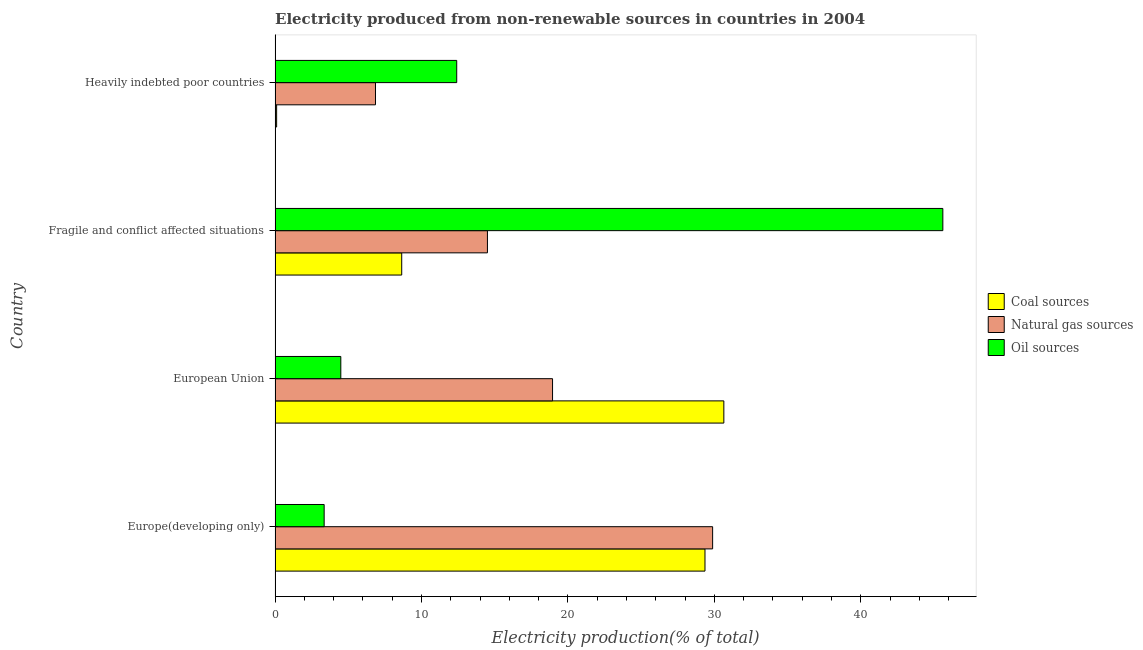How many different coloured bars are there?
Your answer should be very brief. 3. Are the number of bars per tick equal to the number of legend labels?
Provide a short and direct response. Yes. How many bars are there on the 2nd tick from the top?
Your answer should be compact. 3. How many bars are there on the 3rd tick from the bottom?
Offer a terse response. 3. What is the label of the 4th group of bars from the top?
Offer a very short reply. Europe(developing only). What is the percentage of electricity produced by oil sources in European Union?
Your answer should be compact. 4.49. Across all countries, what is the maximum percentage of electricity produced by oil sources?
Your response must be concise. 45.6. Across all countries, what is the minimum percentage of electricity produced by coal?
Provide a succinct answer. 0.11. In which country was the percentage of electricity produced by natural gas maximum?
Provide a short and direct response. Europe(developing only). In which country was the percentage of electricity produced by oil sources minimum?
Your response must be concise. Europe(developing only). What is the total percentage of electricity produced by oil sources in the graph?
Your answer should be very brief. 65.85. What is the difference between the percentage of electricity produced by natural gas in European Union and that in Fragile and conflict affected situations?
Make the answer very short. 4.45. What is the difference between the percentage of electricity produced by oil sources in Fragile and conflict affected situations and the percentage of electricity produced by natural gas in European Union?
Your response must be concise. 26.65. What is the average percentage of electricity produced by coal per country?
Provide a succinct answer. 17.19. What is the difference between the percentage of electricity produced by natural gas and percentage of electricity produced by oil sources in European Union?
Your answer should be very brief. 14.46. In how many countries, is the percentage of electricity produced by natural gas greater than 6 %?
Your response must be concise. 4. What is the ratio of the percentage of electricity produced by oil sources in European Union to that in Heavily indebted poor countries?
Keep it short and to the point. 0.36. Is the percentage of electricity produced by coal in European Union less than that in Heavily indebted poor countries?
Make the answer very short. No. What is the difference between the highest and the second highest percentage of electricity produced by coal?
Ensure brevity in your answer.  1.29. What is the difference between the highest and the lowest percentage of electricity produced by natural gas?
Make the answer very short. 23.02. Is the sum of the percentage of electricity produced by oil sources in European Union and Fragile and conflict affected situations greater than the maximum percentage of electricity produced by natural gas across all countries?
Keep it short and to the point. Yes. What does the 1st bar from the top in Fragile and conflict affected situations represents?
Your answer should be compact. Oil sources. What does the 3rd bar from the bottom in Fragile and conflict affected situations represents?
Your answer should be compact. Oil sources. Are all the bars in the graph horizontal?
Give a very brief answer. Yes. Are the values on the major ticks of X-axis written in scientific E-notation?
Make the answer very short. No. How are the legend labels stacked?
Your answer should be very brief. Vertical. What is the title of the graph?
Provide a short and direct response. Electricity produced from non-renewable sources in countries in 2004. What is the Electricity production(% of total) in Coal sources in Europe(developing only)?
Give a very brief answer. 29.36. What is the Electricity production(% of total) in Natural gas sources in Europe(developing only)?
Your answer should be very brief. 29.88. What is the Electricity production(% of total) of Oil sources in Europe(developing only)?
Offer a terse response. 3.35. What is the Electricity production(% of total) of Coal sources in European Union?
Your response must be concise. 30.65. What is the Electricity production(% of total) in Natural gas sources in European Union?
Provide a short and direct response. 18.95. What is the Electricity production(% of total) of Oil sources in European Union?
Offer a very short reply. 4.49. What is the Electricity production(% of total) of Coal sources in Fragile and conflict affected situations?
Keep it short and to the point. 8.65. What is the Electricity production(% of total) of Natural gas sources in Fragile and conflict affected situations?
Ensure brevity in your answer.  14.5. What is the Electricity production(% of total) in Oil sources in Fragile and conflict affected situations?
Give a very brief answer. 45.6. What is the Electricity production(% of total) in Coal sources in Heavily indebted poor countries?
Offer a very short reply. 0.11. What is the Electricity production(% of total) in Natural gas sources in Heavily indebted poor countries?
Provide a short and direct response. 6.86. What is the Electricity production(% of total) in Oil sources in Heavily indebted poor countries?
Provide a short and direct response. 12.4. Across all countries, what is the maximum Electricity production(% of total) of Coal sources?
Your response must be concise. 30.65. Across all countries, what is the maximum Electricity production(% of total) of Natural gas sources?
Provide a succinct answer. 29.88. Across all countries, what is the maximum Electricity production(% of total) in Oil sources?
Provide a succinct answer. 45.6. Across all countries, what is the minimum Electricity production(% of total) in Coal sources?
Your answer should be very brief. 0.11. Across all countries, what is the minimum Electricity production(% of total) in Natural gas sources?
Offer a very short reply. 6.86. Across all countries, what is the minimum Electricity production(% of total) in Oil sources?
Keep it short and to the point. 3.35. What is the total Electricity production(% of total) in Coal sources in the graph?
Offer a very short reply. 68.76. What is the total Electricity production(% of total) of Natural gas sources in the graph?
Offer a very short reply. 70.19. What is the total Electricity production(% of total) of Oil sources in the graph?
Give a very brief answer. 65.85. What is the difference between the Electricity production(% of total) of Coal sources in Europe(developing only) and that in European Union?
Offer a terse response. -1.29. What is the difference between the Electricity production(% of total) in Natural gas sources in Europe(developing only) and that in European Union?
Provide a short and direct response. 10.93. What is the difference between the Electricity production(% of total) in Oil sources in Europe(developing only) and that in European Union?
Your answer should be very brief. -1.14. What is the difference between the Electricity production(% of total) of Coal sources in Europe(developing only) and that in Fragile and conflict affected situations?
Your response must be concise. 20.71. What is the difference between the Electricity production(% of total) of Natural gas sources in Europe(developing only) and that in Fragile and conflict affected situations?
Provide a succinct answer. 15.38. What is the difference between the Electricity production(% of total) of Oil sources in Europe(developing only) and that in Fragile and conflict affected situations?
Make the answer very short. -42.25. What is the difference between the Electricity production(% of total) of Coal sources in Europe(developing only) and that in Heavily indebted poor countries?
Your answer should be compact. 29.25. What is the difference between the Electricity production(% of total) of Natural gas sources in Europe(developing only) and that in Heavily indebted poor countries?
Make the answer very short. 23.02. What is the difference between the Electricity production(% of total) in Oil sources in Europe(developing only) and that in Heavily indebted poor countries?
Give a very brief answer. -9.05. What is the difference between the Electricity production(% of total) of Coal sources in European Union and that in Fragile and conflict affected situations?
Your response must be concise. 22. What is the difference between the Electricity production(% of total) of Natural gas sources in European Union and that in Fragile and conflict affected situations?
Your response must be concise. 4.45. What is the difference between the Electricity production(% of total) of Oil sources in European Union and that in Fragile and conflict affected situations?
Give a very brief answer. -41.11. What is the difference between the Electricity production(% of total) in Coal sources in European Union and that in Heavily indebted poor countries?
Your answer should be very brief. 30.54. What is the difference between the Electricity production(% of total) in Natural gas sources in European Union and that in Heavily indebted poor countries?
Your answer should be very brief. 12.09. What is the difference between the Electricity production(% of total) in Oil sources in European Union and that in Heavily indebted poor countries?
Offer a terse response. -7.92. What is the difference between the Electricity production(% of total) in Coal sources in Fragile and conflict affected situations and that in Heavily indebted poor countries?
Ensure brevity in your answer.  8.54. What is the difference between the Electricity production(% of total) in Natural gas sources in Fragile and conflict affected situations and that in Heavily indebted poor countries?
Provide a short and direct response. 7.65. What is the difference between the Electricity production(% of total) of Oil sources in Fragile and conflict affected situations and that in Heavily indebted poor countries?
Make the answer very short. 33.2. What is the difference between the Electricity production(% of total) in Coal sources in Europe(developing only) and the Electricity production(% of total) in Natural gas sources in European Union?
Your response must be concise. 10.41. What is the difference between the Electricity production(% of total) of Coal sources in Europe(developing only) and the Electricity production(% of total) of Oil sources in European Union?
Ensure brevity in your answer.  24.87. What is the difference between the Electricity production(% of total) of Natural gas sources in Europe(developing only) and the Electricity production(% of total) of Oil sources in European Union?
Your response must be concise. 25.39. What is the difference between the Electricity production(% of total) of Coal sources in Europe(developing only) and the Electricity production(% of total) of Natural gas sources in Fragile and conflict affected situations?
Offer a terse response. 14.86. What is the difference between the Electricity production(% of total) in Coal sources in Europe(developing only) and the Electricity production(% of total) in Oil sources in Fragile and conflict affected situations?
Ensure brevity in your answer.  -16.24. What is the difference between the Electricity production(% of total) in Natural gas sources in Europe(developing only) and the Electricity production(% of total) in Oil sources in Fragile and conflict affected situations?
Provide a short and direct response. -15.72. What is the difference between the Electricity production(% of total) of Coal sources in Europe(developing only) and the Electricity production(% of total) of Natural gas sources in Heavily indebted poor countries?
Keep it short and to the point. 22.5. What is the difference between the Electricity production(% of total) in Coal sources in Europe(developing only) and the Electricity production(% of total) in Oil sources in Heavily indebted poor countries?
Your answer should be very brief. 16.96. What is the difference between the Electricity production(% of total) of Natural gas sources in Europe(developing only) and the Electricity production(% of total) of Oil sources in Heavily indebted poor countries?
Your answer should be compact. 17.48. What is the difference between the Electricity production(% of total) of Coal sources in European Union and the Electricity production(% of total) of Natural gas sources in Fragile and conflict affected situations?
Keep it short and to the point. 16.14. What is the difference between the Electricity production(% of total) of Coal sources in European Union and the Electricity production(% of total) of Oil sources in Fragile and conflict affected situations?
Offer a terse response. -14.96. What is the difference between the Electricity production(% of total) in Natural gas sources in European Union and the Electricity production(% of total) in Oil sources in Fragile and conflict affected situations?
Your answer should be very brief. -26.65. What is the difference between the Electricity production(% of total) in Coal sources in European Union and the Electricity production(% of total) in Natural gas sources in Heavily indebted poor countries?
Ensure brevity in your answer.  23.79. What is the difference between the Electricity production(% of total) of Coal sources in European Union and the Electricity production(% of total) of Oil sources in Heavily indebted poor countries?
Ensure brevity in your answer.  18.24. What is the difference between the Electricity production(% of total) of Natural gas sources in European Union and the Electricity production(% of total) of Oil sources in Heavily indebted poor countries?
Ensure brevity in your answer.  6.54. What is the difference between the Electricity production(% of total) of Coal sources in Fragile and conflict affected situations and the Electricity production(% of total) of Natural gas sources in Heavily indebted poor countries?
Your answer should be compact. 1.79. What is the difference between the Electricity production(% of total) in Coal sources in Fragile and conflict affected situations and the Electricity production(% of total) in Oil sources in Heavily indebted poor countries?
Offer a very short reply. -3.76. What is the difference between the Electricity production(% of total) in Natural gas sources in Fragile and conflict affected situations and the Electricity production(% of total) in Oil sources in Heavily indebted poor countries?
Your response must be concise. 2.1. What is the average Electricity production(% of total) in Coal sources per country?
Provide a short and direct response. 17.19. What is the average Electricity production(% of total) in Natural gas sources per country?
Offer a terse response. 17.55. What is the average Electricity production(% of total) of Oil sources per country?
Give a very brief answer. 16.46. What is the difference between the Electricity production(% of total) in Coal sources and Electricity production(% of total) in Natural gas sources in Europe(developing only)?
Keep it short and to the point. -0.52. What is the difference between the Electricity production(% of total) of Coal sources and Electricity production(% of total) of Oil sources in Europe(developing only)?
Give a very brief answer. 26.01. What is the difference between the Electricity production(% of total) in Natural gas sources and Electricity production(% of total) in Oil sources in Europe(developing only)?
Offer a terse response. 26.53. What is the difference between the Electricity production(% of total) in Coal sources and Electricity production(% of total) in Natural gas sources in European Union?
Keep it short and to the point. 11.7. What is the difference between the Electricity production(% of total) of Coal sources and Electricity production(% of total) of Oil sources in European Union?
Offer a terse response. 26.16. What is the difference between the Electricity production(% of total) of Natural gas sources and Electricity production(% of total) of Oil sources in European Union?
Provide a succinct answer. 14.46. What is the difference between the Electricity production(% of total) in Coal sources and Electricity production(% of total) in Natural gas sources in Fragile and conflict affected situations?
Your response must be concise. -5.85. What is the difference between the Electricity production(% of total) of Coal sources and Electricity production(% of total) of Oil sources in Fragile and conflict affected situations?
Provide a short and direct response. -36.95. What is the difference between the Electricity production(% of total) of Natural gas sources and Electricity production(% of total) of Oil sources in Fragile and conflict affected situations?
Keep it short and to the point. -31.1. What is the difference between the Electricity production(% of total) in Coal sources and Electricity production(% of total) in Natural gas sources in Heavily indebted poor countries?
Your answer should be compact. -6.75. What is the difference between the Electricity production(% of total) of Coal sources and Electricity production(% of total) of Oil sources in Heavily indebted poor countries?
Offer a very short reply. -12.3. What is the difference between the Electricity production(% of total) in Natural gas sources and Electricity production(% of total) in Oil sources in Heavily indebted poor countries?
Give a very brief answer. -5.55. What is the ratio of the Electricity production(% of total) in Coal sources in Europe(developing only) to that in European Union?
Keep it short and to the point. 0.96. What is the ratio of the Electricity production(% of total) in Natural gas sources in Europe(developing only) to that in European Union?
Your answer should be very brief. 1.58. What is the ratio of the Electricity production(% of total) of Oil sources in Europe(developing only) to that in European Union?
Offer a terse response. 0.75. What is the ratio of the Electricity production(% of total) in Coal sources in Europe(developing only) to that in Fragile and conflict affected situations?
Provide a short and direct response. 3.39. What is the ratio of the Electricity production(% of total) of Natural gas sources in Europe(developing only) to that in Fragile and conflict affected situations?
Give a very brief answer. 2.06. What is the ratio of the Electricity production(% of total) of Oil sources in Europe(developing only) to that in Fragile and conflict affected situations?
Provide a short and direct response. 0.07. What is the ratio of the Electricity production(% of total) of Coal sources in Europe(developing only) to that in Heavily indebted poor countries?
Your answer should be compact. 279.34. What is the ratio of the Electricity production(% of total) of Natural gas sources in Europe(developing only) to that in Heavily indebted poor countries?
Offer a terse response. 4.36. What is the ratio of the Electricity production(% of total) of Oil sources in Europe(developing only) to that in Heavily indebted poor countries?
Your response must be concise. 0.27. What is the ratio of the Electricity production(% of total) in Coal sources in European Union to that in Fragile and conflict affected situations?
Ensure brevity in your answer.  3.54. What is the ratio of the Electricity production(% of total) of Natural gas sources in European Union to that in Fragile and conflict affected situations?
Keep it short and to the point. 1.31. What is the ratio of the Electricity production(% of total) in Oil sources in European Union to that in Fragile and conflict affected situations?
Your answer should be compact. 0.1. What is the ratio of the Electricity production(% of total) in Coal sources in European Union to that in Heavily indebted poor countries?
Your response must be concise. 291.59. What is the ratio of the Electricity production(% of total) of Natural gas sources in European Union to that in Heavily indebted poor countries?
Provide a succinct answer. 2.76. What is the ratio of the Electricity production(% of total) of Oil sources in European Union to that in Heavily indebted poor countries?
Your answer should be compact. 0.36. What is the ratio of the Electricity production(% of total) in Coal sources in Fragile and conflict affected situations to that in Heavily indebted poor countries?
Keep it short and to the point. 82.28. What is the ratio of the Electricity production(% of total) of Natural gas sources in Fragile and conflict affected situations to that in Heavily indebted poor countries?
Your response must be concise. 2.12. What is the ratio of the Electricity production(% of total) in Oil sources in Fragile and conflict affected situations to that in Heavily indebted poor countries?
Offer a terse response. 3.68. What is the difference between the highest and the second highest Electricity production(% of total) in Coal sources?
Make the answer very short. 1.29. What is the difference between the highest and the second highest Electricity production(% of total) of Natural gas sources?
Your answer should be compact. 10.93. What is the difference between the highest and the second highest Electricity production(% of total) of Oil sources?
Make the answer very short. 33.2. What is the difference between the highest and the lowest Electricity production(% of total) of Coal sources?
Keep it short and to the point. 30.54. What is the difference between the highest and the lowest Electricity production(% of total) in Natural gas sources?
Provide a short and direct response. 23.02. What is the difference between the highest and the lowest Electricity production(% of total) of Oil sources?
Provide a succinct answer. 42.25. 